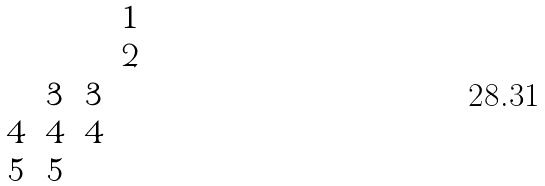Convert formula to latex. <formula><loc_0><loc_0><loc_500><loc_500>\begin{matrix} & & & 1 \\ & & & 2 \\ & 3 & 3 & \\ 4 & 4 & 4 & \\ 5 & 5 & & \end{matrix}</formula> 